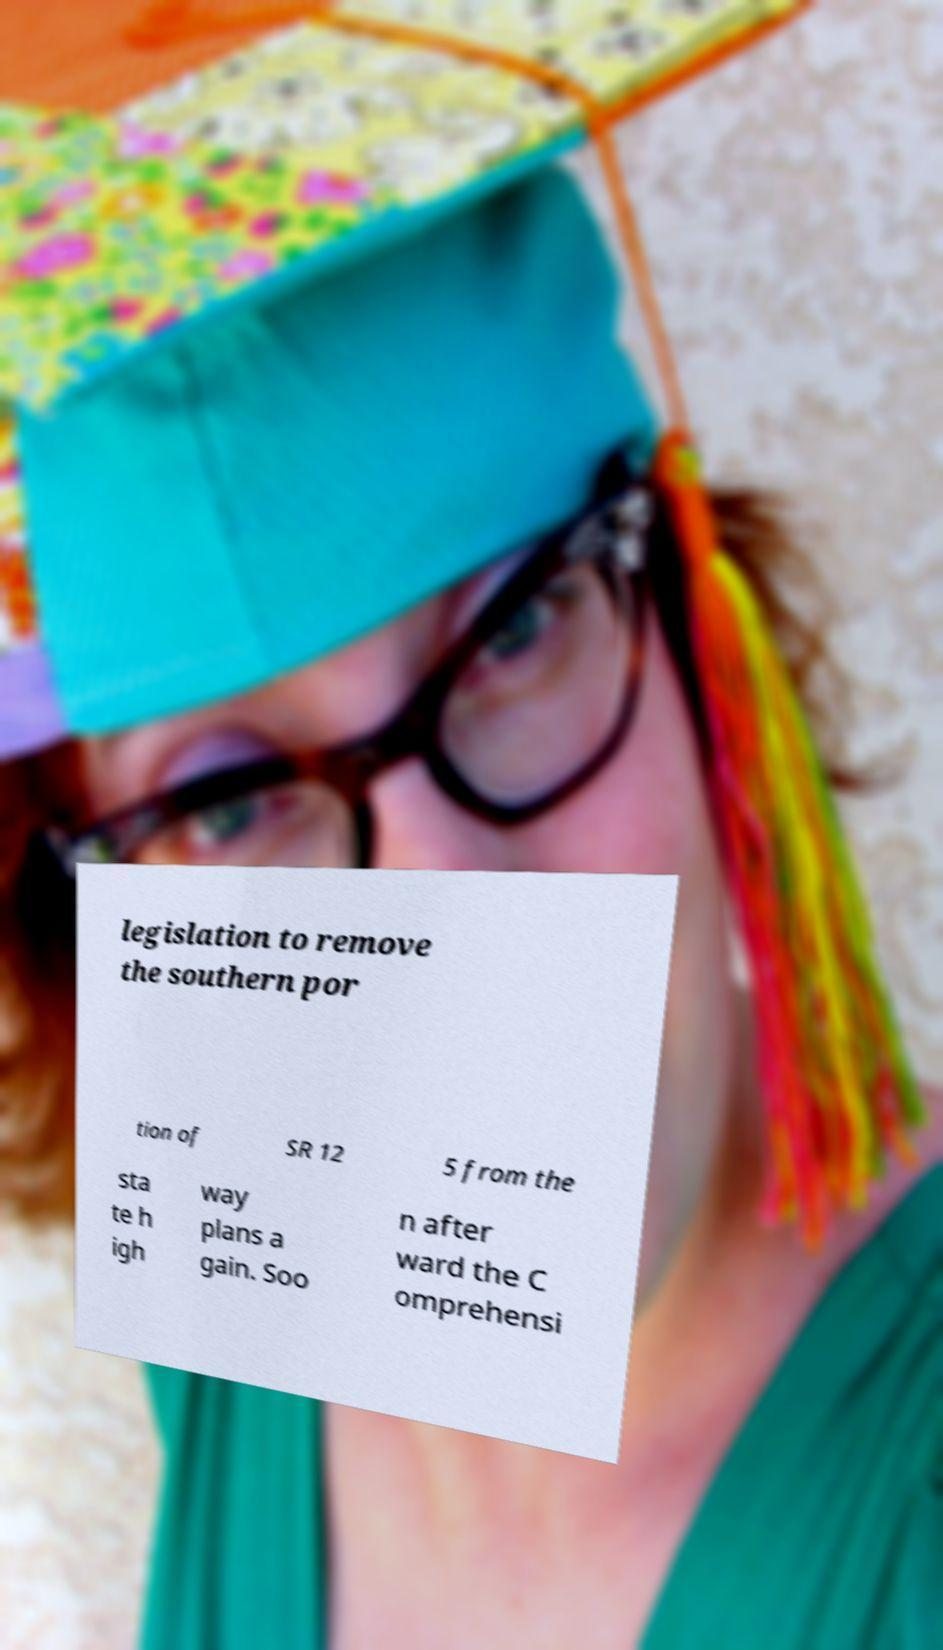Please identify and transcribe the text found in this image. legislation to remove the southern por tion of SR 12 5 from the sta te h igh way plans a gain. Soo n after ward the C omprehensi 